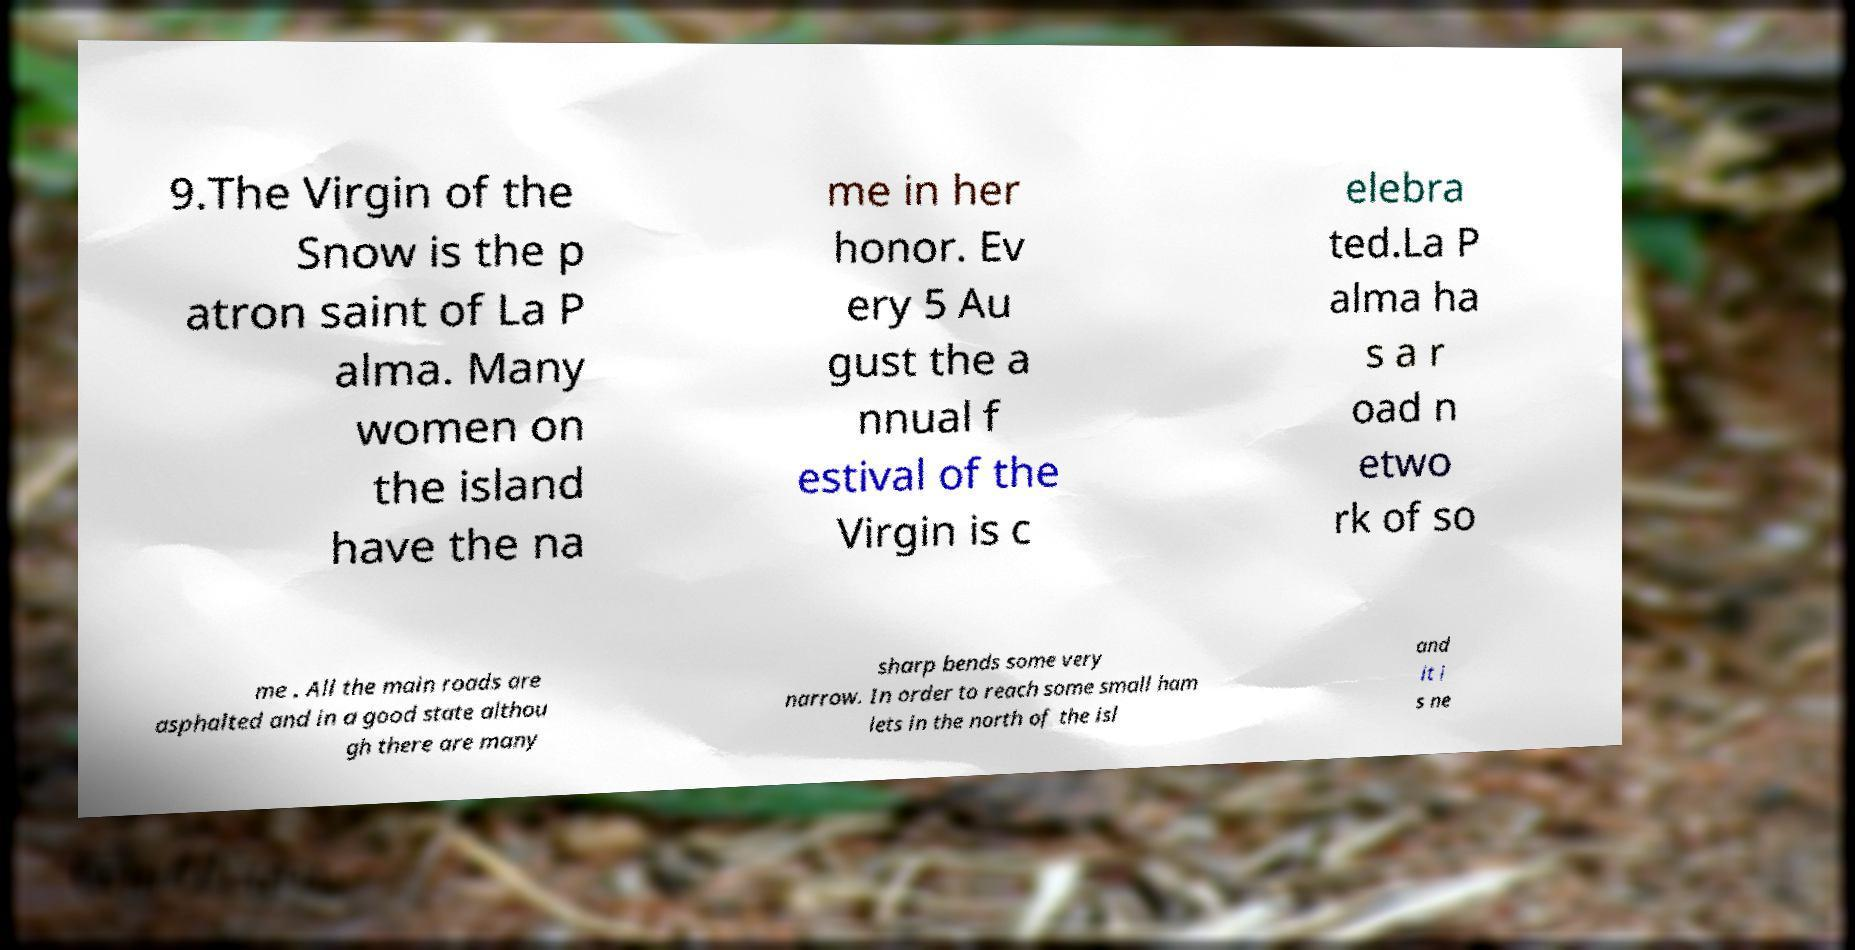Can you accurately transcribe the text from the provided image for me? 9.The Virgin of the Snow is the p atron saint of La P alma. Many women on the island have the na me in her honor. Ev ery 5 Au gust the a nnual f estival of the Virgin is c elebra ted.La P alma ha s a r oad n etwo rk of so me . All the main roads are asphalted and in a good state althou gh there are many sharp bends some very narrow. In order to reach some small ham lets in the north of the isl and it i s ne 